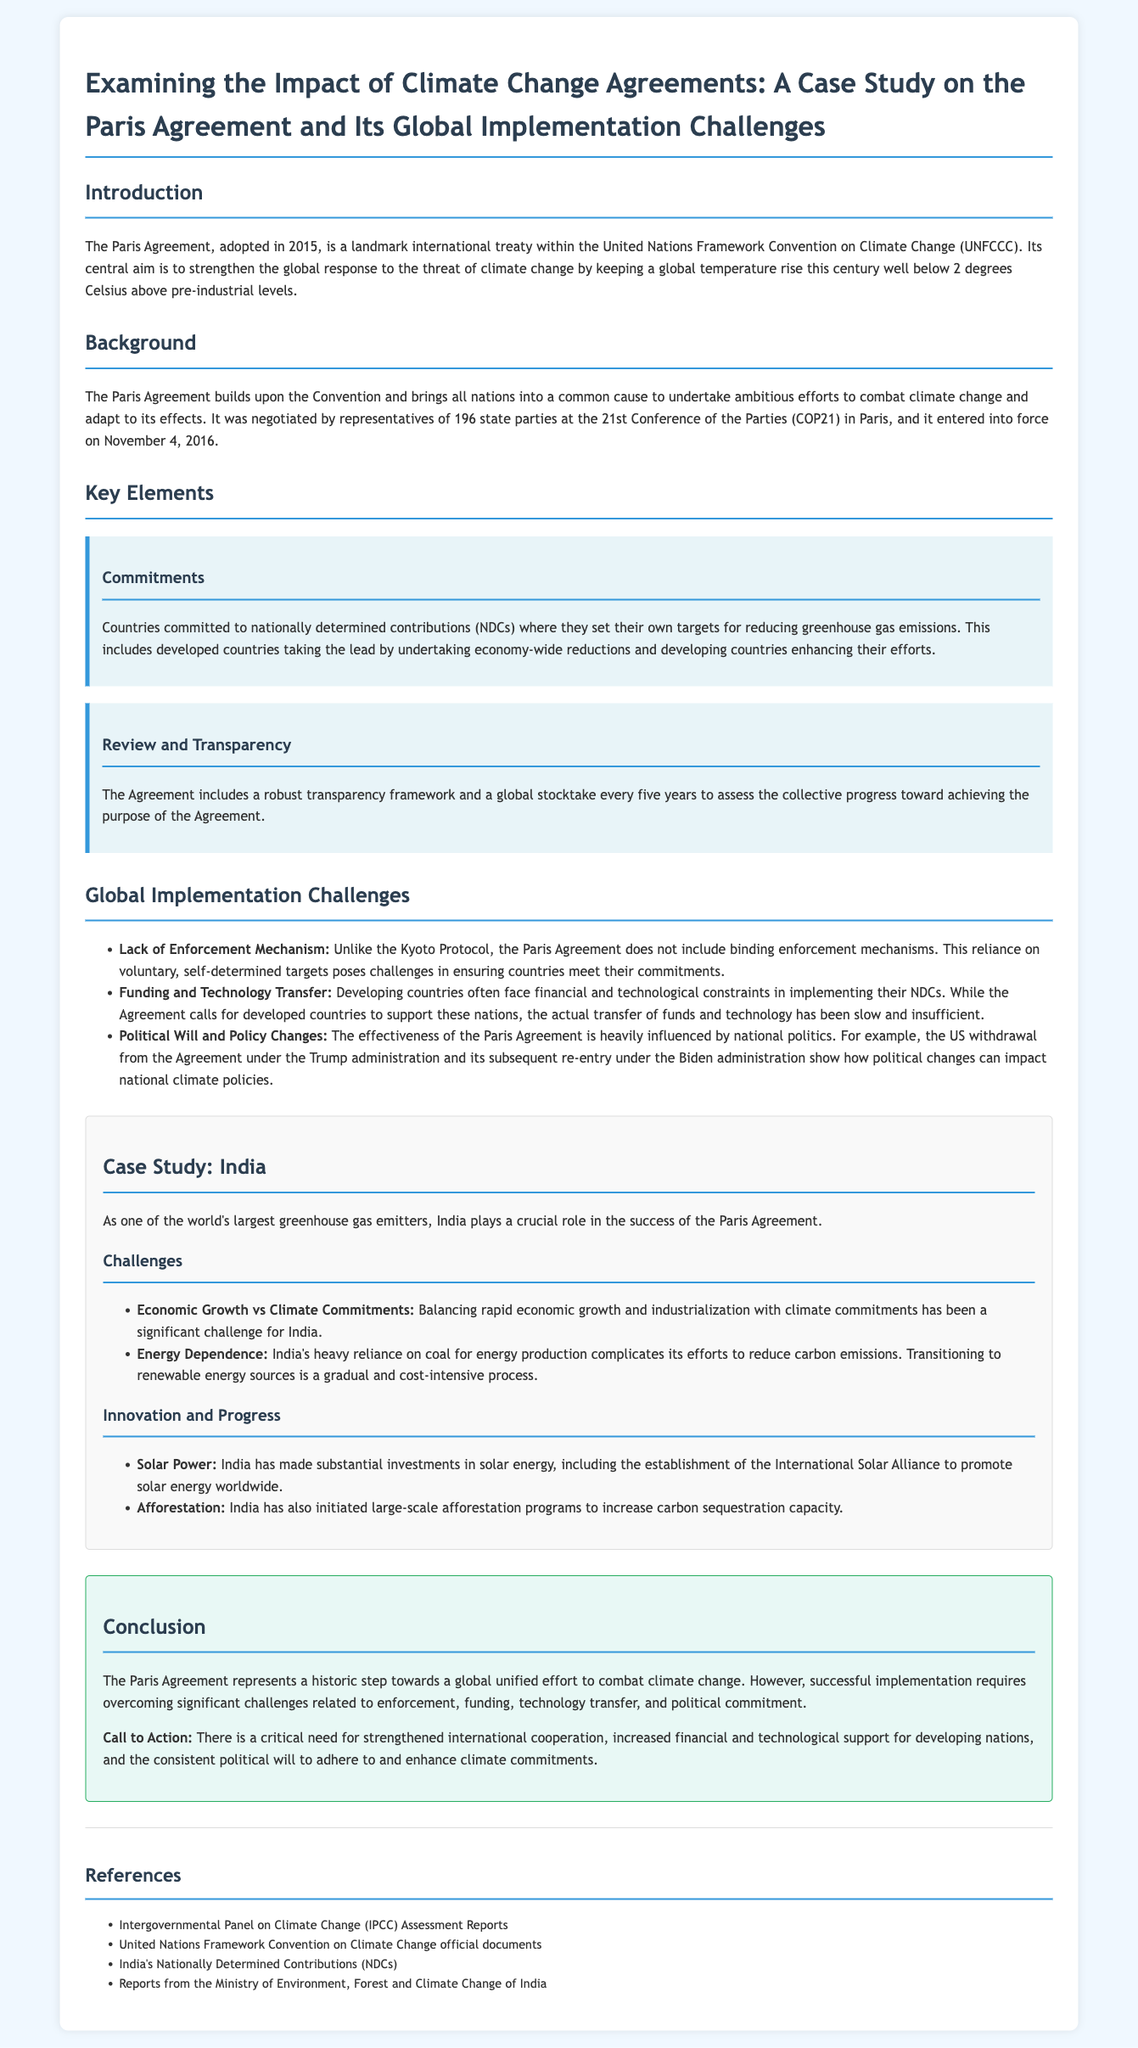What is the central aim of the Paris Agreement? The central aim of the Paris Agreement is to strengthen the global response to the threat of climate change by keeping a global temperature rise well below 2 degrees Celsius above pre-industrial levels.
Answer: to strengthen the global response to climate change When did the Paris Agreement enter into force? The Paris Agreement entered into force on November 4, 2016.
Answer: November 4, 2016 What do NDCs stand for in the context of the Paris Agreement? NDCs in the context of the Paris Agreement stand for nationally determined contributions.
Answer: nationally determined contributions What is a significant challenge faced by India regarding the Paris Agreement? A significant challenge faced by India is balancing rapid economic growth and industrialization with climate commitments.
Answer: balancing rapid economic growth with climate commitments What technology transfer issue do developing countries face? Developing countries face financial and technological constraints in implementing their NDCs.
Answer: financial and technological constraints How often is the global stocktake conducted under the Paris Agreement? The global stocktake is conducted every five years under the Paris Agreement.
Answer: every five years What is one innovation India has made towards renewable energy? India has made substantial investments in solar energy.
Answer: solar energy What was the political event that impacted US involvement in the Paris Agreement? The political event was the US withdrawal from the Agreement under the Trump administration.
Answer: US withdrawal under Trump What is a call to action emphasized in the conclusion of the document? A call to action emphasized is strengthened international cooperation.
Answer: strengthened international cooperation 